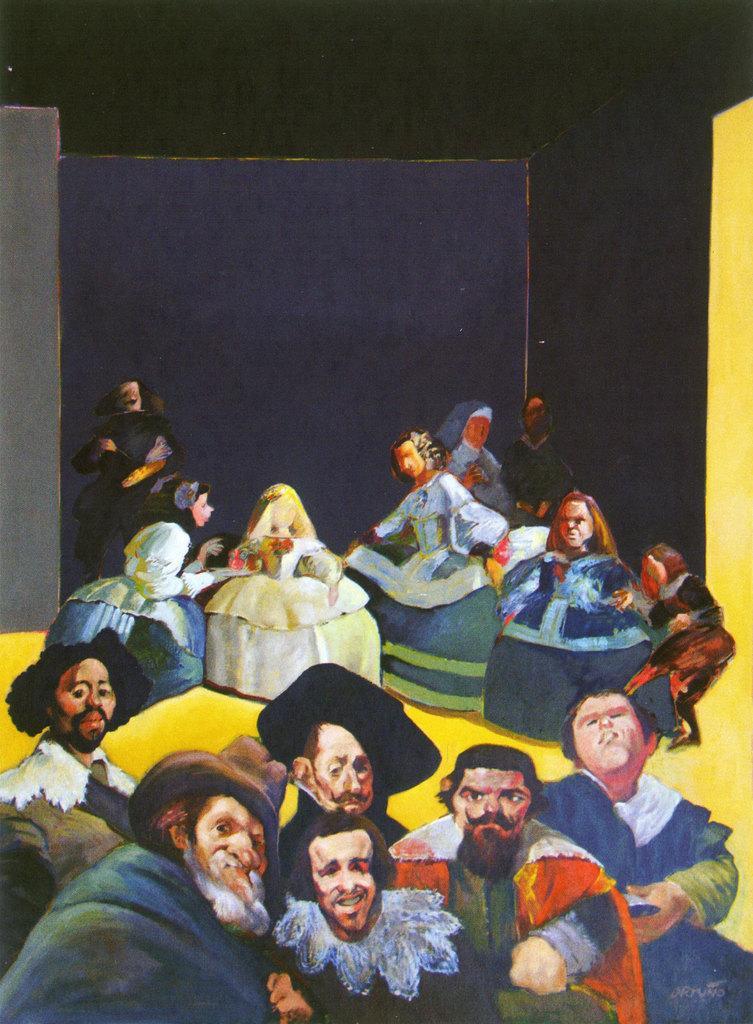Could you give a brief overview of what you see in this image? This is an animated image in the foreground there are some people who are standing, and in the background there are a group of woman who are dancing. In the background there is a wall. 